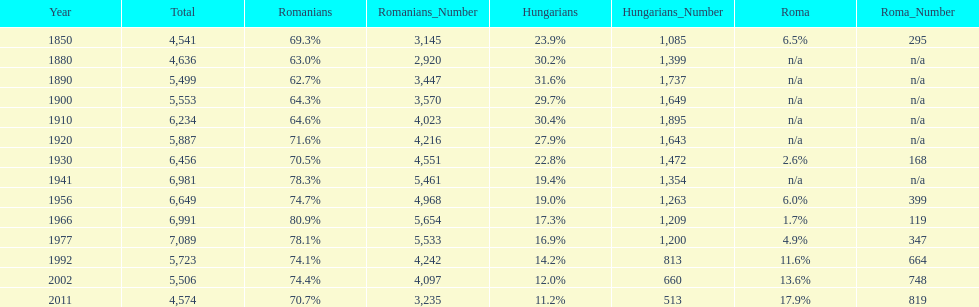What year had the highest total number? 1977. 